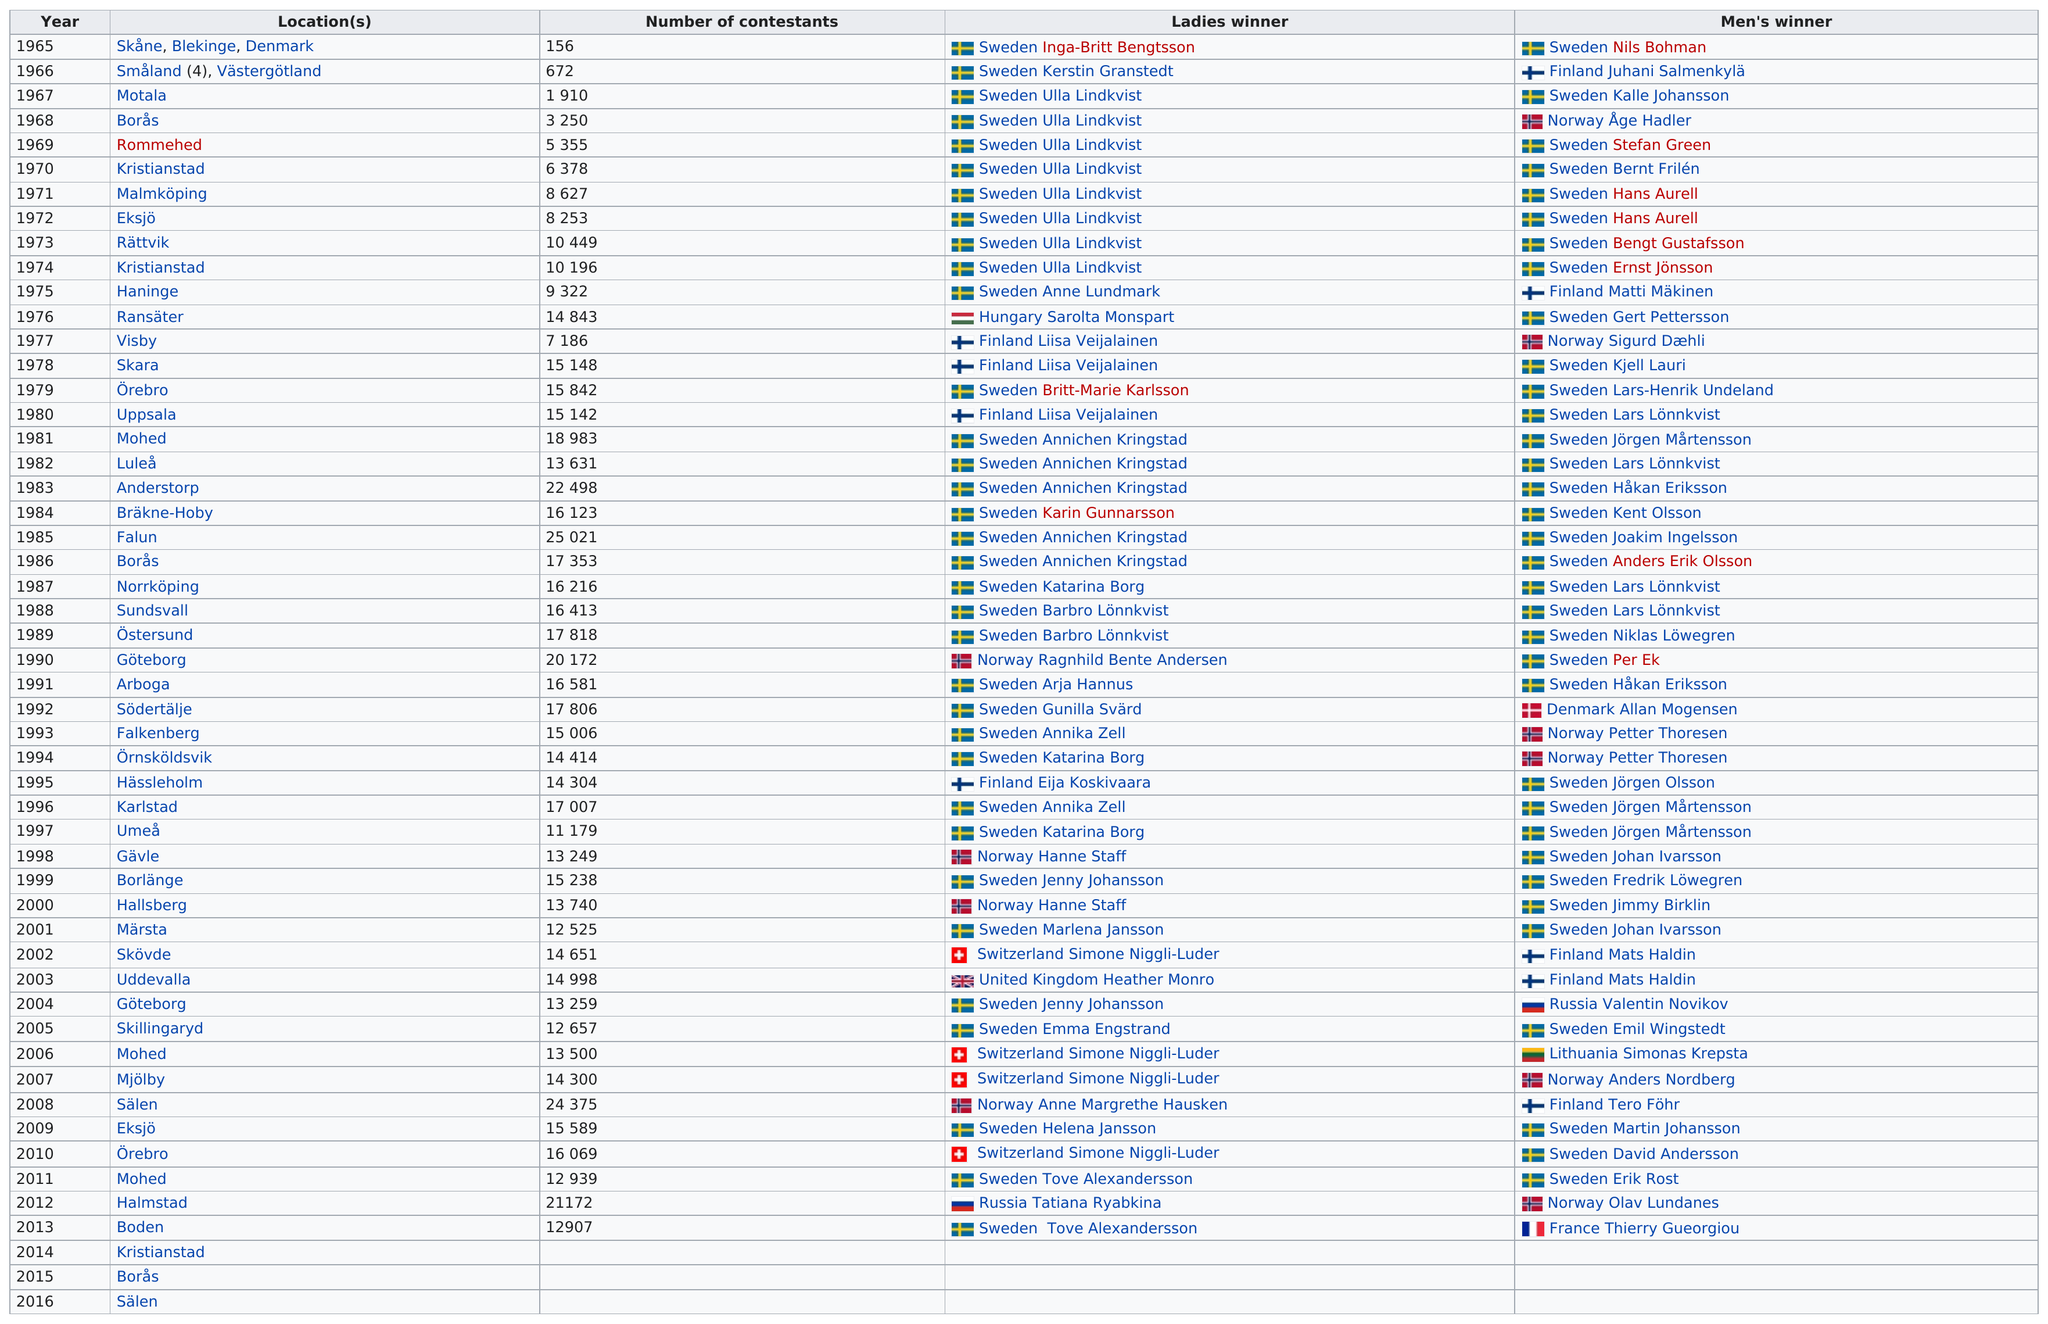Highlight a few significant elements in this photo. In the year 1965, there were less than 672 contestants. Forty-five locations had at least 5,000 or more contestants. Falun Gong competition had the largest number of contestants. The year that had the highest number of contestants competing for the title was 1985. In 1972, a total of 8,253 contestants participated in the event. 